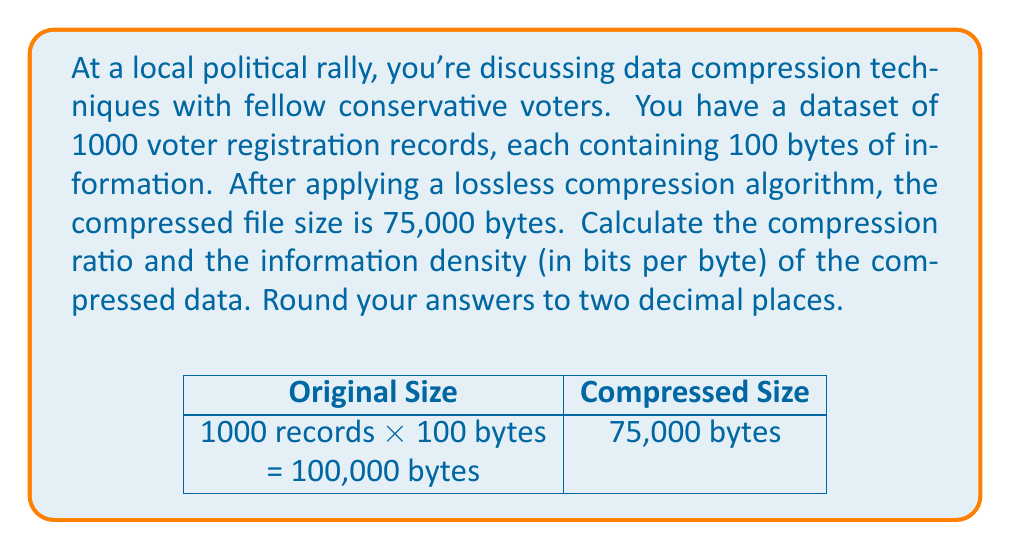Help me with this question. Let's approach this step-by-step:

1) First, calculate the original file size:
   Original size = 1000 records × 100 bytes/record = 100,000 bytes

2) The compressed file size is given as 75,000 bytes.

3) Compression ratio is calculated as:
   $$ \text{Compression Ratio} = \frac{\text{Original Size}}{\text{Compressed Size}} $$

   $$ \text{Compression Ratio} = \frac{100,000}{75,000} = 1.3333... $$

   Rounded to two decimal places: 1.33

4) To calculate information density, we need to convert bytes to bits:
   Original information = 100,000 bytes × 8 bits/byte = 800,000 bits

5) Information density is the amount of original information divided by the size of the compressed data:
   $$ \text{Information Density} = \frac{\text{Original Information (bits)}}{\text{Compressed Size (bytes)}} $$

   $$ \text{Information Density} = \frac{800,000 \text{ bits}}{75,000 \text{ bytes}} = 10.6666... \text{ bits/byte} $$

   Rounded to two decimal places: 10.67 bits/byte
Answer: Compression Ratio: 1.33, Information Density: 10.67 bits/byte 